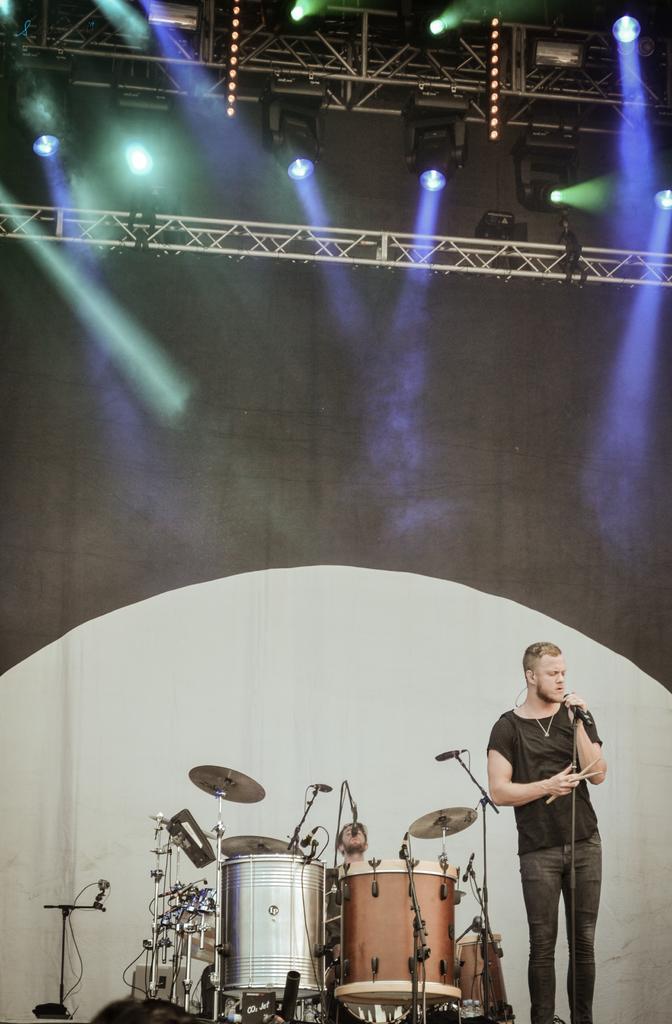Describe this image in one or two sentences. This image is clicked in a concert. There is a man in the bottom. He is holding a mic and singing something. There are drums in the bottom of the image. There are lights on the top of the image the is mic near the drums too. Person who is standing is wearing black shirt and black pant. He is also wearing chain. 